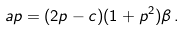<formula> <loc_0><loc_0><loc_500><loc_500>a p = ( 2 p - c ) ( 1 + p ^ { 2 } ) \beta \, .</formula> 